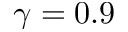Convert formula to latex. <formula><loc_0><loc_0><loc_500><loc_500>\gamma = 0 . 9</formula> 